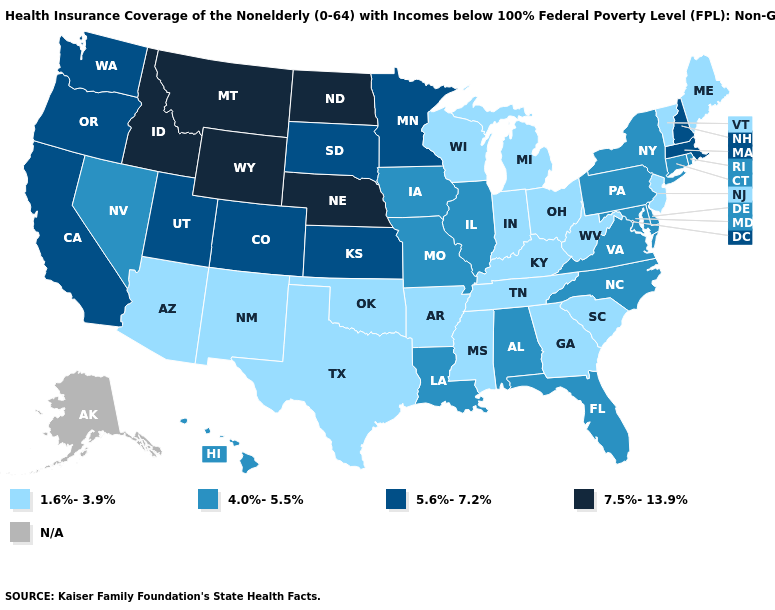Name the states that have a value in the range 7.5%-13.9%?
Short answer required. Idaho, Montana, Nebraska, North Dakota, Wyoming. Does Pennsylvania have the lowest value in the Northeast?
Keep it brief. No. Among the states that border Colorado , does Oklahoma have the lowest value?
Keep it brief. Yes. Which states have the highest value in the USA?
Write a very short answer. Idaho, Montana, Nebraska, North Dakota, Wyoming. What is the value of Missouri?
Quick response, please. 4.0%-5.5%. What is the value of Wisconsin?
Be succinct. 1.6%-3.9%. What is the value of Montana?
Quick response, please. 7.5%-13.9%. How many symbols are there in the legend?
Concise answer only. 5. What is the value of Texas?
Concise answer only. 1.6%-3.9%. Which states have the lowest value in the USA?
Short answer required. Arizona, Arkansas, Georgia, Indiana, Kentucky, Maine, Michigan, Mississippi, New Jersey, New Mexico, Ohio, Oklahoma, South Carolina, Tennessee, Texas, Vermont, West Virginia, Wisconsin. Among the states that border Florida , does Alabama have the lowest value?
Answer briefly. No. Name the states that have a value in the range 5.6%-7.2%?
Answer briefly. California, Colorado, Kansas, Massachusetts, Minnesota, New Hampshire, Oregon, South Dakota, Utah, Washington. How many symbols are there in the legend?
Keep it brief. 5. What is the value of North Carolina?
Be succinct. 4.0%-5.5%. 